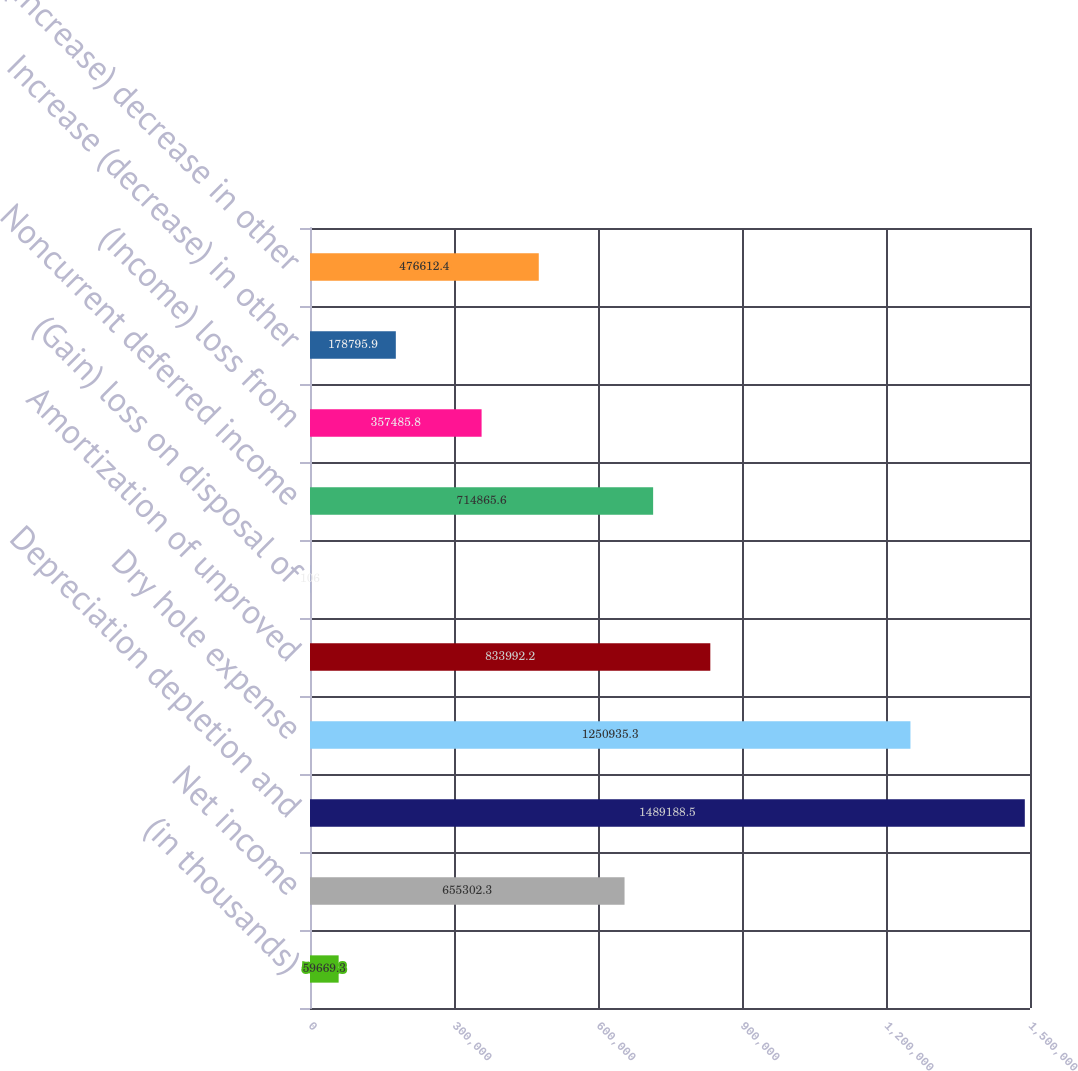<chart> <loc_0><loc_0><loc_500><loc_500><bar_chart><fcel>(in thousands)<fcel>Net income<fcel>Depreciation depletion and<fcel>Dry hole expense<fcel>Amortization of unproved<fcel>(Gain) loss on disposal of<fcel>Noncurrent deferred income<fcel>(Income) loss from<fcel>Increase (decrease) in other<fcel>(Increase) decrease in other<nl><fcel>59669.3<fcel>655302<fcel>1.48919e+06<fcel>1.25094e+06<fcel>833992<fcel>106<fcel>714866<fcel>357486<fcel>178796<fcel>476612<nl></chart> 